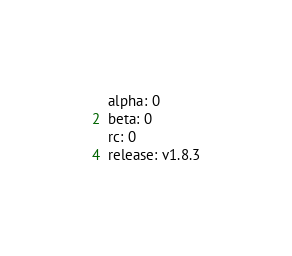Convert code to text. <code><loc_0><loc_0><loc_500><loc_500><_YAML_>alpha: 0
beta: 0
rc: 0
release: v1.8.3
</code> 